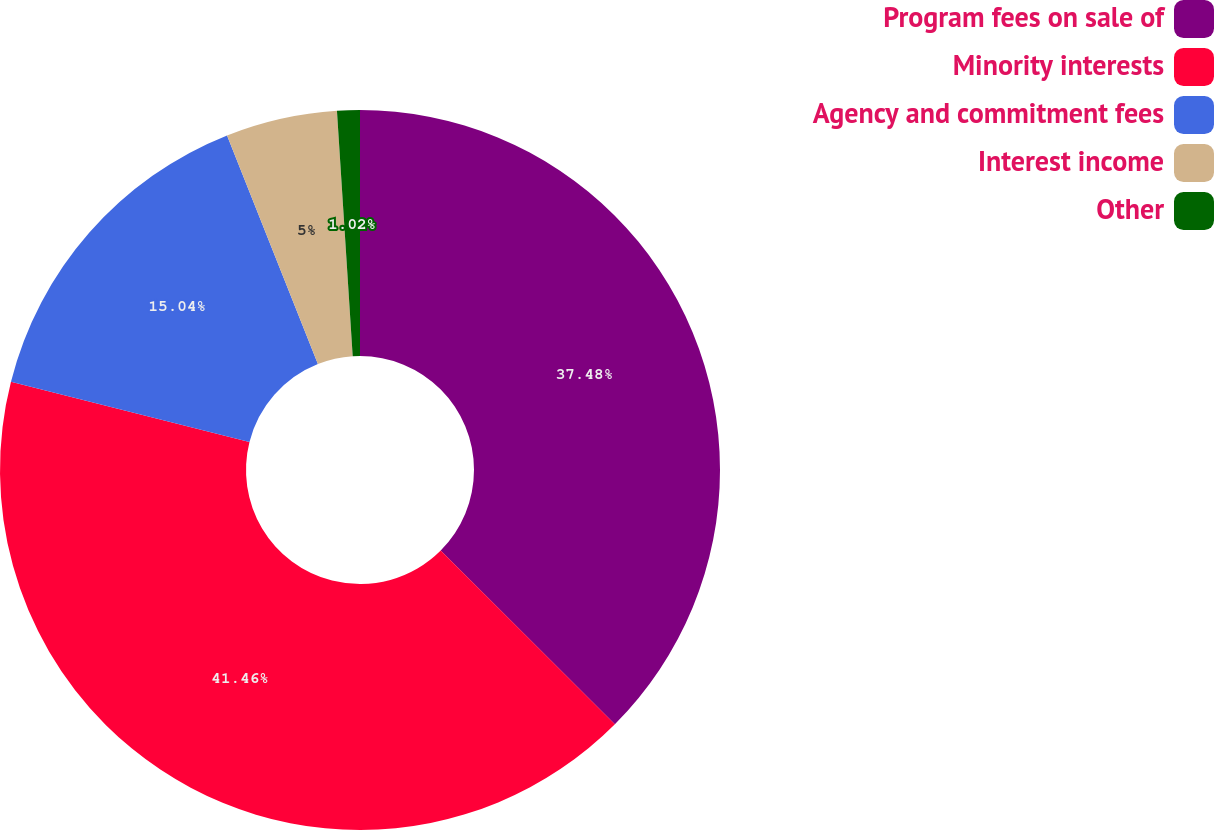Convert chart to OTSL. <chart><loc_0><loc_0><loc_500><loc_500><pie_chart><fcel>Program fees on sale of<fcel>Minority interests<fcel>Agency and commitment fees<fcel>Interest income<fcel>Other<nl><fcel>37.48%<fcel>41.46%<fcel>15.04%<fcel>5.0%<fcel>1.02%<nl></chart> 